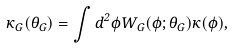<formula> <loc_0><loc_0><loc_500><loc_500>\kappa _ { G } ( \theta _ { G } ) = \int d ^ { 2 } \phi W _ { G } ( \phi ; \theta _ { G } ) \kappa ( \phi ) ,</formula> 